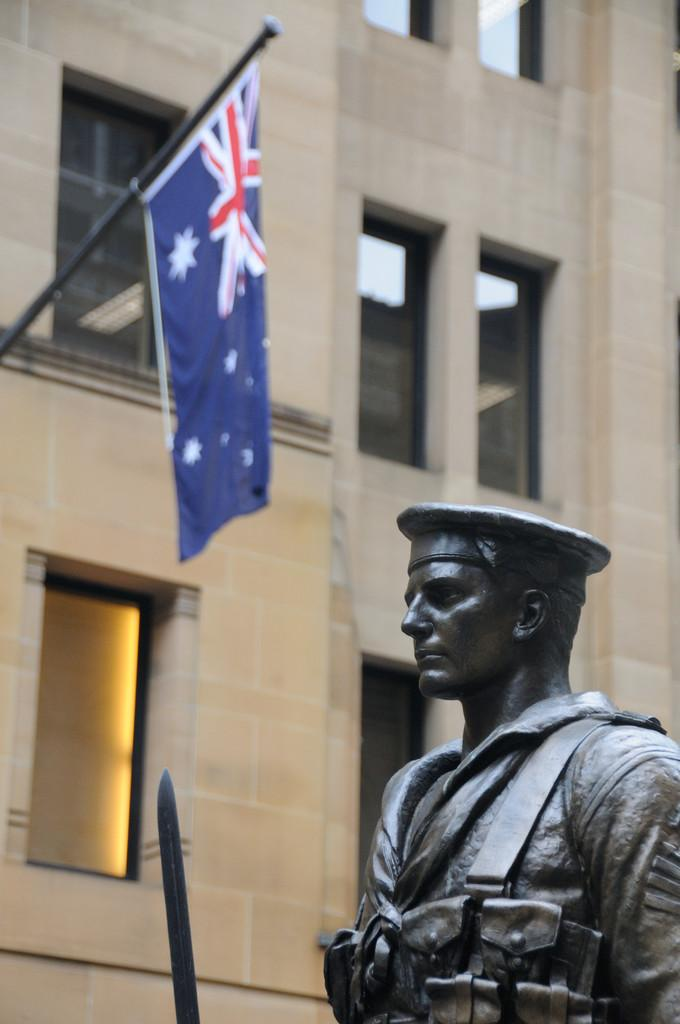What is present in the image? There is a person in the image. What is in front of the person? There is an object in front of the person. What can be seen in the background of the image? There is a building and a flag in the background of the image. What type of locket is the person wearing in the image? There is no locket visible in the image. Is the person holding a knife in the image? There is no knife present in the image. 